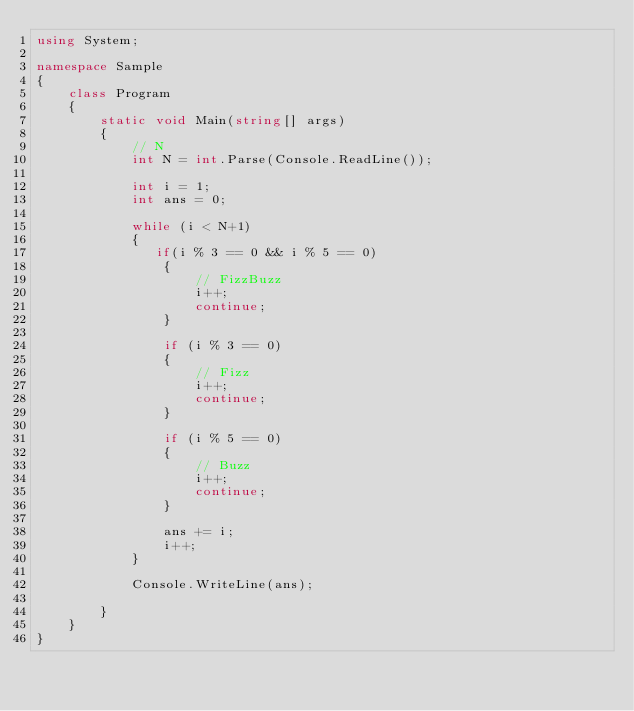Convert code to text. <code><loc_0><loc_0><loc_500><loc_500><_C#_>using System;

namespace Sample
{
    class Program
    {
        static void Main(string[] args)
        {
            // N
            int N = int.Parse(Console.ReadLine());

            int i = 1;
            int ans = 0;

            while (i < N+1)
            {
               if(i % 3 == 0 && i % 5 == 0)
                {
                    // FizzBuzz
                    i++;
                    continue;
                }

                if (i % 3 == 0)
                {
                    // Fizz
                    i++;
                    continue;
                }

                if (i % 5 == 0)
                {
                    // Buzz
                    i++;
                    continue;
                }

                ans += i;
                i++;
            }

            Console.WriteLine(ans);

        }
    }
}
</code> 